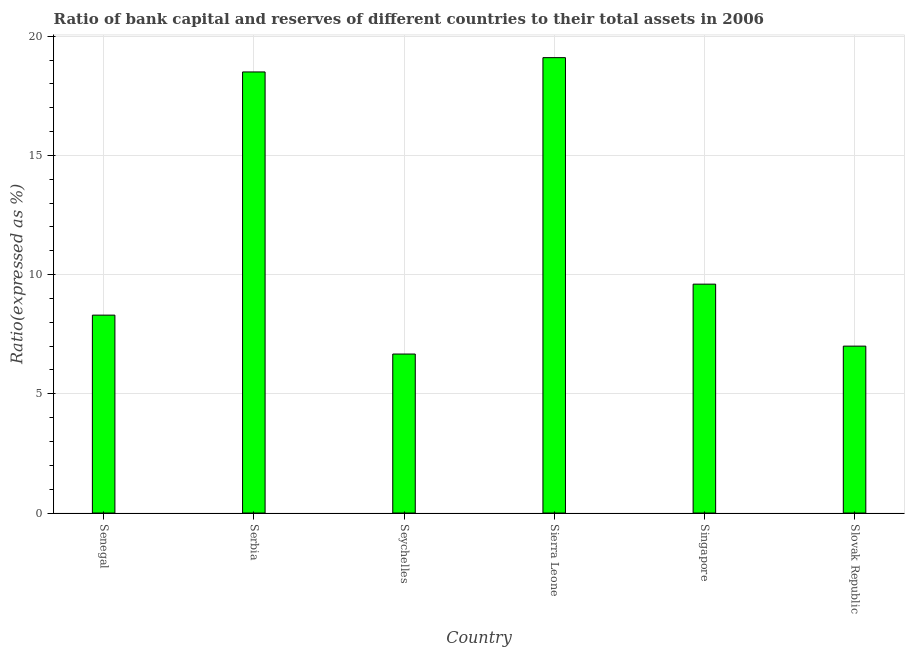What is the title of the graph?
Provide a short and direct response. Ratio of bank capital and reserves of different countries to their total assets in 2006. What is the label or title of the X-axis?
Provide a succinct answer. Country. What is the label or title of the Y-axis?
Provide a succinct answer. Ratio(expressed as %). What is the bank capital to assets ratio in Singapore?
Your response must be concise. 9.6. Across all countries, what is the minimum bank capital to assets ratio?
Provide a succinct answer. 6.67. In which country was the bank capital to assets ratio maximum?
Provide a succinct answer. Sierra Leone. In which country was the bank capital to assets ratio minimum?
Keep it short and to the point. Seychelles. What is the sum of the bank capital to assets ratio?
Provide a short and direct response. 69.17. What is the difference between the bank capital to assets ratio in Serbia and Singapore?
Offer a terse response. 8.9. What is the average bank capital to assets ratio per country?
Provide a short and direct response. 11.53. What is the median bank capital to assets ratio?
Ensure brevity in your answer.  8.95. What is the ratio of the bank capital to assets ratio in Senegal to that in Serbia?
Offer a very short reply. 0.45. Is the bank capital to assets ratio in Senegal less than that in Singapore?
Offer a very short reply. Yes. Is the sum of the bank capital to assets ratio in Senegal and Sierra Leone greater than the maximum bank capital to assets ratio across all countries?
Keep it short and to the point. Yes. What is the difference between the highest and the lowest bank capital to assets ratio?
Make the answer very short. 12.43. How many bars are there?
Your response must be concise. 6. Are all the bars in the graph horizontal?
Make the answer very short. No. What is the difference between two consecutive major ticks on the Y-axis?
Your response must be concise. 5. What is the Ratio(expressed as %) of Serbia?
Offer a very short reply. 18.5. What is the Ratio(expressed as %) of Seychelles?
Provide a short and direct response. 6.67. What is the Ratio(expressed as %) in Sierra Leone?
Make the answer very short. 19.1. What is the difference between the Ratio(expressed as %) in Senegal and Serbia?
Ensure brevity in your answer.  -10.2. What is the difference between the Ratio(expressed as %) in Senegal and Seychelles?
Offer a terse response. 1.63. What is the difference between the Ratio(expressed as %) in Senegal and Singapore?
Your response must be concise. -1.3. What is the difference between the Ratio(expressed as %) in Senegal and Slovak Republic?
Make the answer very short. 1.3. What is the difference between the Ratio(expressed as %) in Serbia and Seychelles?
Your answer should be very brief. 11.83. What is the difference between the Ratio(expressed as %) in Serbia and Sierra Leone?
Offer a very short reply. -0.6. What is the difference between the Ratio(expressed as %) in Serbia and Slovak Republic?
Provide a short and direct response. 11.5. What is the difference between the Ratio(expressed as %) in Seychelles and Sierra Leone?
Make the answer very short. -12.43. What is the difference between the Ratio(expressed as %) in Seychelles and Singapore?
Make the answer very short. -2.93. What is the difference between the Ratio(expressed as %) in Seychelles and Slovak Republic?
Provide a short and direct response. -0.33. What is the ratio of the Ratio(expressed as %) in Senegal to that in Serbia?
Ensure brevity in your answer.  0.45. What is the ratio of the Ratio(expressed as %) in Senegal to that in Seychelles?
Your answer should be very brief. 1.25. What is the ratio of the Ratio(expressed as %) in Senegal to that in Sierra Leone?
Your answer should be compact. 0.43. What is the ratio of the Ratio(expressed as %) in Senegal to that in Singapore?
Ensure brevity in your answer.  0.86. What is the ratio of the Ratio(expressed as %) in Senegal to that in Slovak Republic?
Make the answer very short. 1.19. What is the ratio of the Ratio(expressed as %) in Serbia to that in Seychelles?
Make the answer very short. 2.77. What is the ratio of the Ratio(expressed as %) in Serbia to that in Sierra Leone?
Provide a succinct answer. 0.97. What is the ratio of the Ratio(expressed as %) in Serbia to that in Singapore?
Make the answer very short. 1.93. What is the ratio of the Ratio(expressed as %) in Serbia to that in Slovak Republic?
Offer a terse response. 2.64. What is the ratio of the Ratio(expressed as %) in Seychelles to that in Sierra Leone?
Your answer should be compact. 0.35. What is the ratio of the Ratio(expressed as %) in Seychelles to that in Singapore?
Your response must be concise. 0.69. What is the ratio of the Ratio(expressed as %) in Seychelles to that in Slovak Republic?
Your answer should be compact. 0.95. What is the ratio of the Ratio(expressed as %) in Sierra Leone to that in Singapore?
Offer a very short reply. 1.99. What is the ratio of the Ratio(expressed as %) in Sierra Leone to that in Slovak Republic?
Offer a very short reply. 2.73. What is the ratio of the Ratio(expressed as %) in Singapore to that in Slovak Republic?
Offer a terse response. 1.37. 